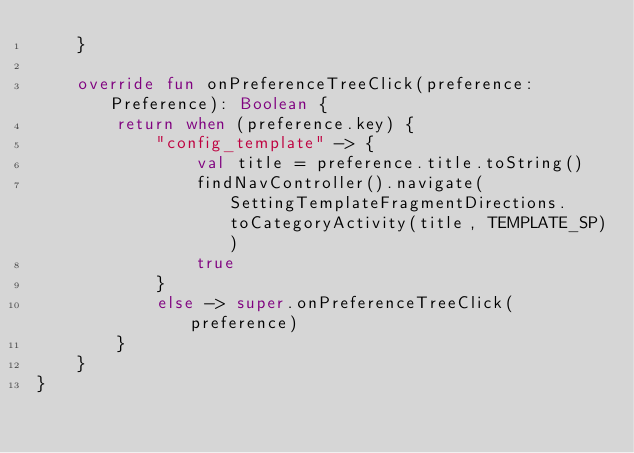Convert code to text. <code><loc_0><loc_0><loc_500><loc_500><_Kotlin_>    }

    override fun onPreferenceTreeClick(preference: Preference): Boolean {
        return when (preference.key) {
            "config_template" -> {
                val title = preference.title.toString()
                findNavController().navigate(SettingTemplateFragmentDirections.toCategoryActivity(title, TEMPLATE_SP))
                true
            }
            else -> super.onPreferenceTreeClick(preference)
        }
    }
}</code> 